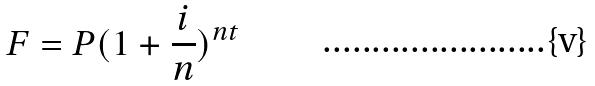Convert formula to latex. <formula><loc_0><loc_0><loc_500><loc_500>F = P ( 1 + \frac { i } { n } ) ^ { n t }</formula> 